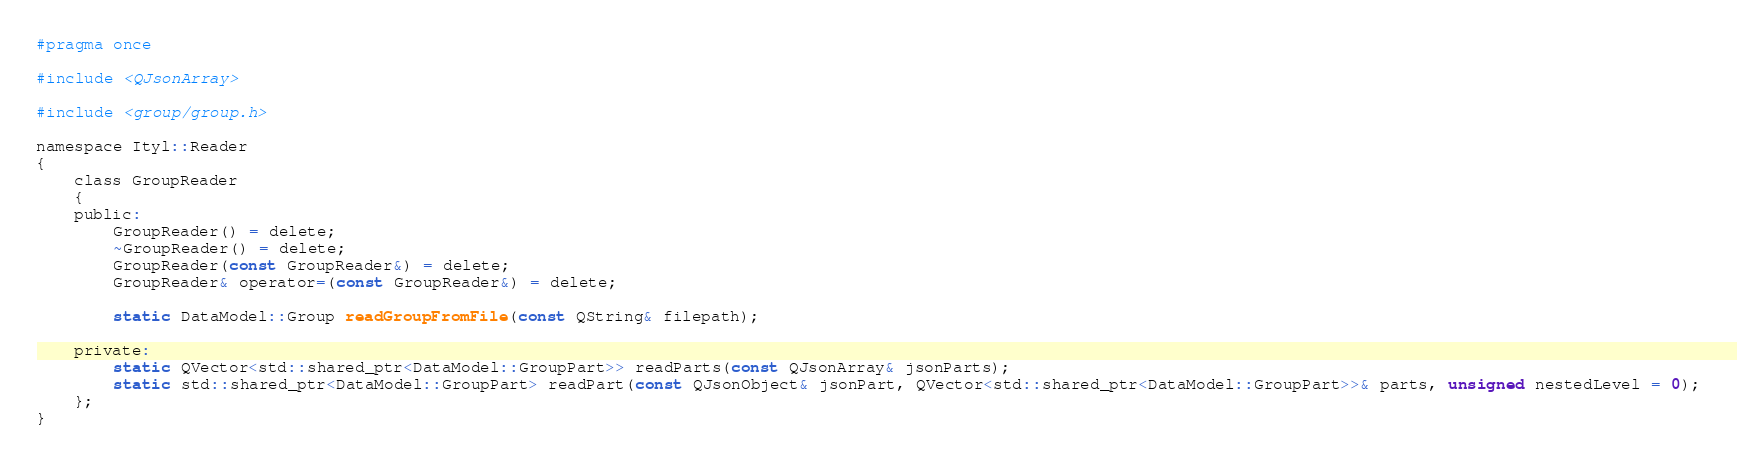Convert code to text. <code><loc_0><loc_0><loc_500><loc_500><_C_>#pragma once

#include <QJsonArray>

#include <group/group.h>

namespace Ityl::Reader
{
    class GroupReader
    {
    public:
        GroupReader() = delete;
        ~GroupReader() = delete;
        GroupReader(const GroupReader&) = delete;
        GroupReader& operator=(const GroupReader&) = delete;

        static DataModel::Group readGroupFromFile(const QString& filepath);

    private:
        static QVector<std::shared_ptr<DataModel::GroupPart>> readParts(const QJsonArray& jsonParts);
        static std::shared_ptr<DataModel::GroupPart> readPart(const QJsonObject& jsonPart, QVector<std::shared_ptr<DataModel::GroupPart>>& parts, unsigned nestedLevel = 0);
    };
}
</code> 